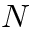<formula> <loc_0><loc_0><loc_500><loc_500>N</formula> 